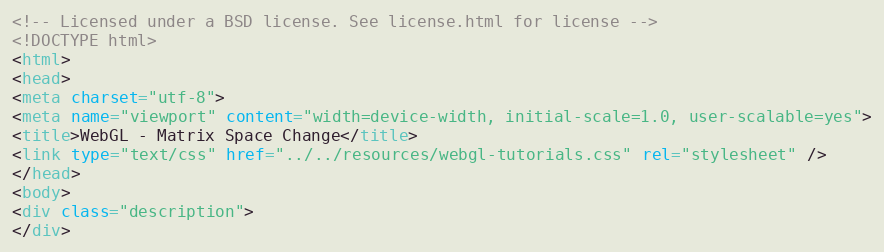<code> <loc_0><loc_0><loc_500><loc_500><_HTML_><!-- Licensed under a BSD license. See license.html for license -->
<!DOCTYPE html>
<html>
<head>
<meta charset="utf-8">
<meta name="viewport" content="width=device-width, initial-scale=1.0, user-scalable=yes">
<title>WebGL - Matrix Space Change</title>
<link type="text/css" href="../../resources/webgl-tutorials.css" rel="stylesheet" />
</head>
<body>
<div class="description">
</div></code> 